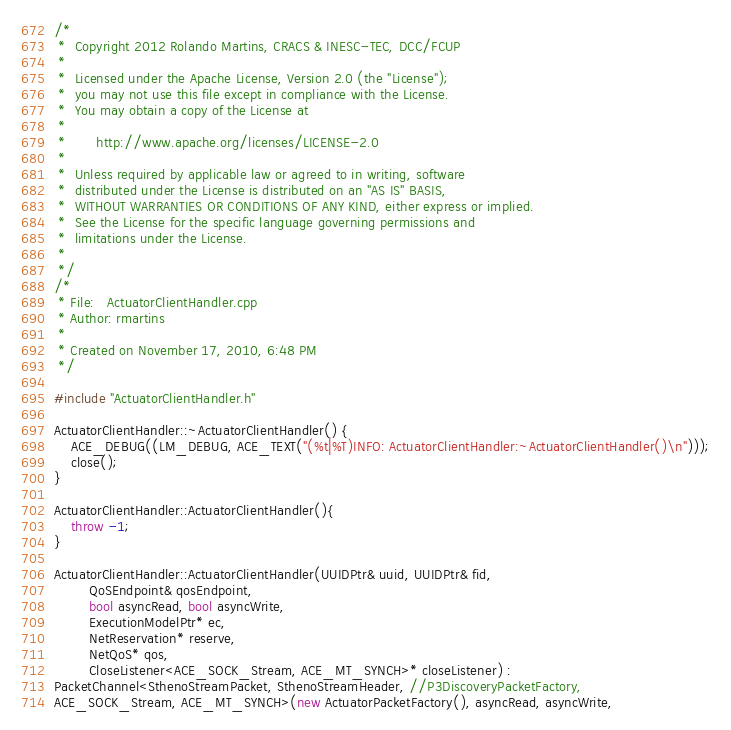Convert code to text. <code><loc_0><loc_0><loc_500><loc_500><_C++_>/*
 *  Copyright 2012 Rolando Martins, CRACS & INESC-TEC, DCC/FCUP
 *
 *  Licensed under the Apache License, Version 2.0 (the "License");
 *  you may not use this file except in compliance with the License.
 *  You may obtain a copy of the License at
 *   
 *       http://www.apache.org/licenses/LICENSE-2.0
 *
 *  Unless required by applicable law or agreed to in writing, software
 *  distributed under the License is distributed on an "AS IS" BASIS,
 *  WITHOUT WARRANTIES OR CONDITIONS OF ANY KIND, either express or implied.
 *  See the License for the specific language governing permissions and
 *  limitations under the License.
 * 
 */
/* 
 * File:   ActuatorClientHandler.cpp
 * Author: rmartins
 * 
 * Created on November 17, 2010, 6:48 PM
 */

#include "ActuatorClientHandler.h"

ActuatorClientHandler::~ActuatorClientHandler() {
    ACE_DEBUG((LM_DEBUG, ACE_TEXT("(%t|%T)INFO: ActuatorClientHandler:~ActuatorClientHandler()\n")));
    close();
}

ActuatorClientHandler::ActuatorClientHandler(){
    throw -1;
}

ActuatorClientHandler::ActuatorClientHandler(UUIDPtr& uuid, UUIDPtr& fid,
        QoSEndpoint& qosEndpoint,
        bool asyncRead, bool asyncWrite,
        ExecutionModelPtr* ec,
        NetReservation* reserve,
        NetQoS* qos,
        CloseListener<ACE_SOCK_Stream, ACE_MT_SYNCH>* closeListener) :
PacketChannel<SthenoStreamPacket, SthenoStreamHeader, //P3DiscoveryPacketFactory,
ACE_SOCK_Stream, ACE_MT_SYNCH>(new ActuatorPacketFactory(), asyncRead, asyncWrite,</code> 